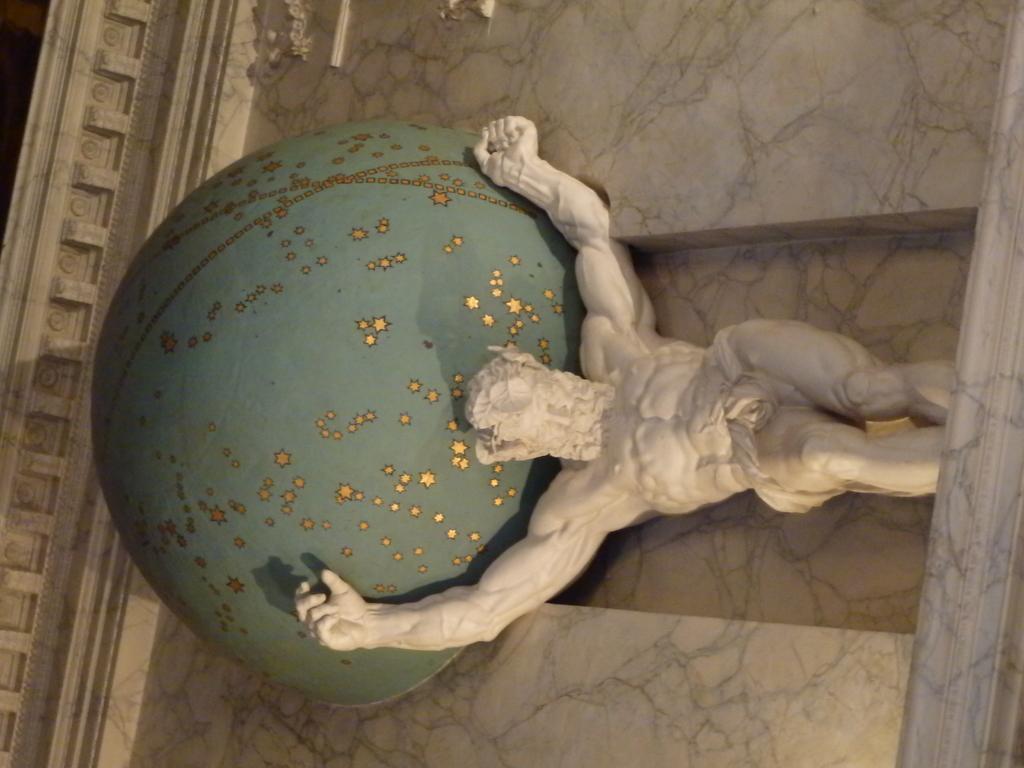Can you describe this image briefly? In this image I can see a statue and wall. 